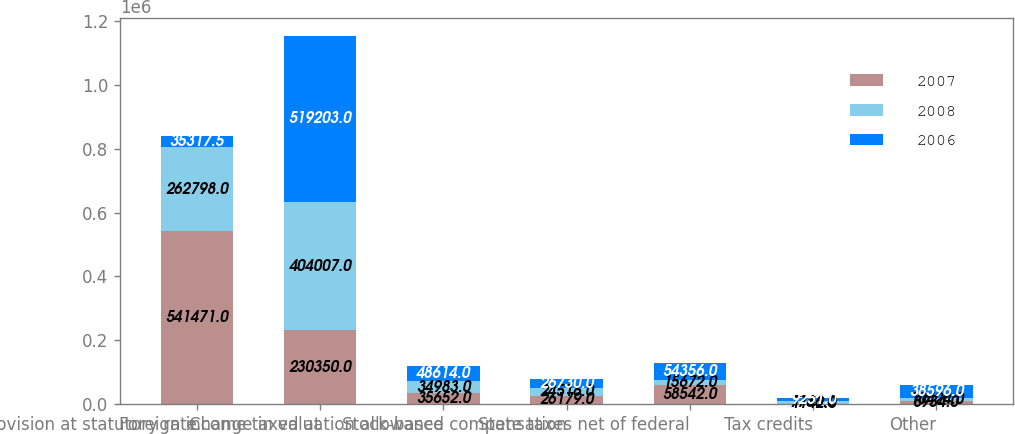Convert chart. <chart><loc_0><loc_0><loc_500><loc_500><stacked_bar_chart><ecel><fcel>Provision at statutory rate<fcel>Foreign income taxed at<fcel>Change in valuation allowance<fcel>Stock-based compensation<fcel>State taxes net of federal<fcel>Tax credits<fcel>Other<nl><fcel>2007<fcel>541471<fcel>230350<fcel>35652<fcel>26179<fcel>58542<fcel>1142<fcel>8934<nl><fcel>2008<fcel>262798<fcel>404007<fcel>34983<fcel>24516<fcel>15672<fcel>7766<fcel>10424<nl><fcel>2006<fcel>35317.5<fcel>519203<fcel>48614<fcel>26730<fcel>54356<fcel>9251<fcel>38596<nl></chart> 